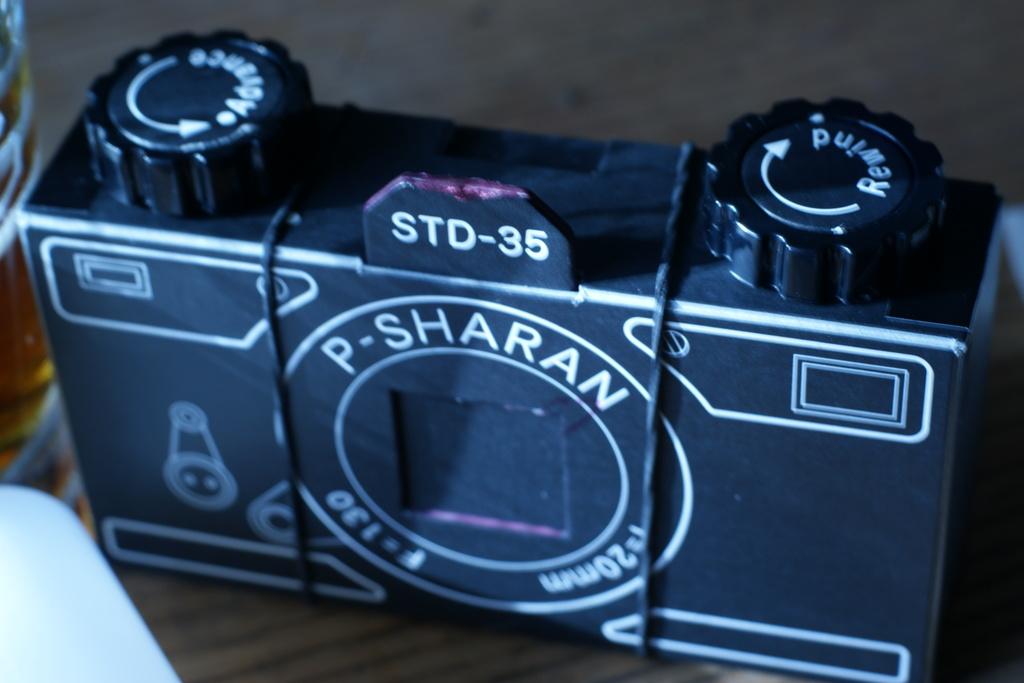What model number is this?
Offer a terse response. Std-35. What brand of camera?
Your answer should be very brief. P-sharan. 